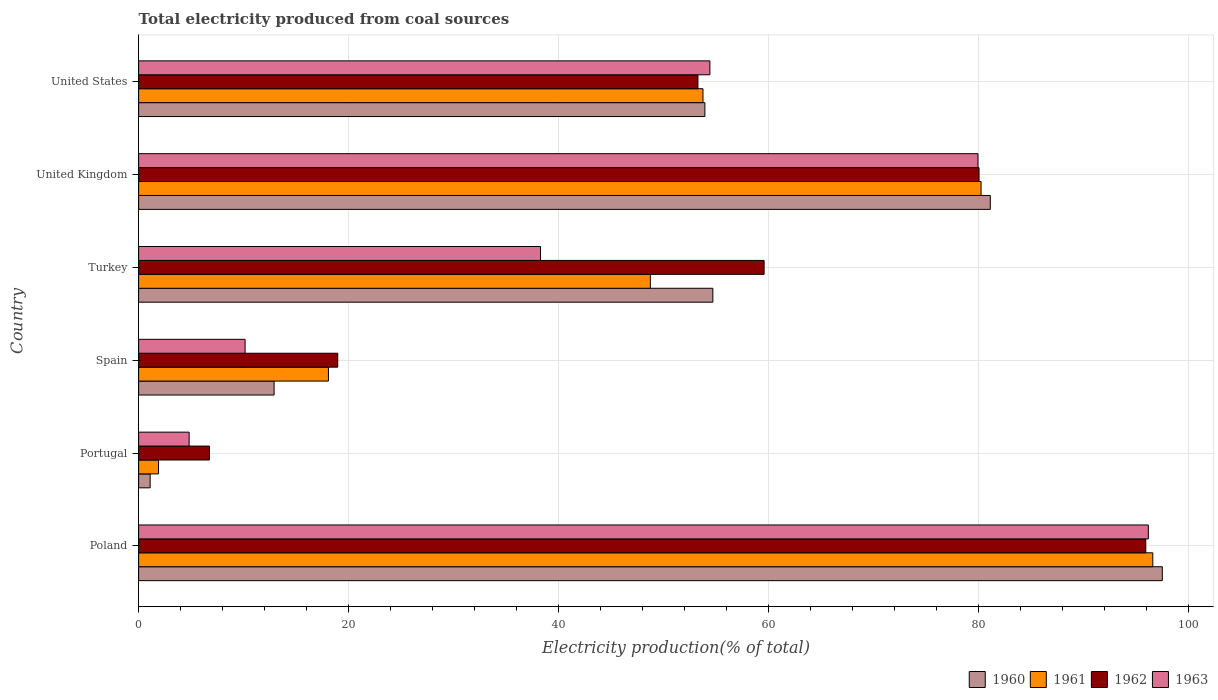How many groups of bars are there?
Provide a succinct answer. 6. How many bars are there on the 2nd tick from the bottom?
Give a very brief answer. 4. What is the total electricity produced in 1960 in Poland?
Your answer should be very brief. 97.46. Across all countries, what is the maximum total electricity produced in 1963?
Make the answer very short. 96.13. Across all countries, what is the minimum total electricity produced in 1961?
Offer a very short reply. 1.89. In which country was the total electricity produced in 1963 maximum?
Give a very brief answer. Poland. In which country was the total electricity produced in 1961 minimum?
Ensure brevity in your answer.  Portugal. What is the total total electricity produced in 1960 in the graph?
Provide a short and direct response. 301.13. What is the difference between the total electricity produced in 1961 in Poland and that in United States?
Keep it short and to the point. 42.83. What is the difference between the total electricity produced in 1963 in United States and the total electricity produced in 1960 in Spain?
Your answer should be compact. 41.49. What is the average total electricity produced in 1961 per country?
Your answer should be compact. 49.86. What is the difference between the total electricity produced in 1960 and total electricity produced in 1961 in Turkey?
Offer a very short reply. 5.95. In how many countries, is the total electricity produced in 1962 greater than 36 %?
Offer a very short reply. 4. What is the ratio of the total electricity produced in 1961 in Spain to that in United Kingdom?
Make the answer very short. 0.23. Is the total electricity produced in 1961 in Spain less than that in Turkey?
Your response must be concise. Yes. What is the difference between the highest and the second highest total electricity produced in 1963?
Offer a terse response. 16.22. What is the difference between the highest and the lowest total electricity produced in 1962?
Offer a terse response. 89.15. Is the sum of the total electricity produced in 1962 in Poland and Portugal greater than the maximum total electricity produced in 1963 across all countries?
Give a very brief answer. Yes. Is it the case that in every country, the sum of the total electricity produced in 1960 and total electricity produced in 1961 is greater than the total electricity produced in 1963?
Provide a short and direct response. No. How many bars are there?
Provide a short and direct response. 24. How many countries are there in the graph?
Your response must be concise. 6. Are the values on the major ticks of X-axis written in scientific E-notation?
Provide a short and direct response. No. Does the graph contain grids?
Your answer should be compact. Yes. How many legend labels are there?
Offer a very short reply. 4. What is the title of the graph?
Offer a very short reply. Total electricity produced from coal sources. What is the label or title of the X-axis?
Provide a short and direct response. Electricity production(% of total). What is the Electricity production(% of total) in 1960 in Poland?
Your response must be concise. 97.46. What is the Electricity production(% of total) of 1961 in Poland?
Keep it short and to the point. 96.56. What is the Electricity production(% of total) of 1962 in Poland?
Give a very brief answer. 95.89. What is the Electricity production(% of total) of 1963 in Poland?
Your response must be concise. 96.13. What is the Electricity production(% of total) of 1960 in Portugal?
Make the answer very short. 1.1. What is the Electricity production(% of total) in 1961 in Portugal?
Provide a succinct answer. 1.89. What is the Electricity production(% of total) of 1962 in Portugal?
Provide a succinct answer. 6.74. What is the Electricity production(% of total) of 1963 in Portugal?
Offer a very short reply. 4.81. What is the Electricity production(% of total) of 1960 in Spain?
Offer a terse response. 12.9. What is the Electricity production(% of total) in 1961 in Spain?
Your answer should be compact. 18.07. What is the Electricity production(% of total) in 1962 in Spain?
Give a very brief answer. 18.96. What is the Electricity production(% of total) of 1963 in Spain?
Provide a short and direct response. 10.14. What is the Electricity production(% of total) in 1960 in Turkey?
Offer a terse response. 54.67. What is the Electricity production(% of total) in 1961 in Turkey?
Ensure brevity in your answer.  48.72. What is the Electricity production(% of total) of 1962 in Turkey?
Your answer should be very brief. 59.55. What is the Electricity production(% of total) of 1963 in Turkey?
Offer a terse response. 38.26. What is the Electricity production(% of total) in 1960 in United Kingdom?
Keep it short and to the point. 81.09. What is the Electricity production(% of total) in 1961 in United Kingdom?
Your answer should be very brief. 80.21. What is the Electricity production(% of total) in 1962 in United Kingdom?
Make the answer very short. 80.01. What is the Electricity production(% of total) of 1963 in United Kingdom?
Ensure brevity in your answer.  79.91. What is the Electricity production(% of total) in 1960 in United States?
Your answer should be compact. 53.91. What is the Electricity production(% of total) of 1961 in United States?
Give a very brief answer. 53.73. What is the Electricity production(% of total) of 1962 in United States?
Provide a succinct answer. 53.25. What is the Electricity production(% of total) in 1963 in United States?
Make the answer very short. 54.39. Across all countries, what is the maximum Electricity production(% of total) of 1960?
Keep it short and to the point. 97.46. Across all countries, what is the maximum Electricity production(% of total) of 1961?
Provide a succinct answer. 96.56. Across all countries, what is the maximum Electricity production(% of total) in 1962?
Your answer should be very brief. 95.89. Across all countries, what is the maximum Electricity production(% of total) in 1963?
Your answer should be very brief. 96.13. Across all countries, what is the minimum Electricity production(% of total) of 1960?
Keep it short and to the point. 1.1. Across all countries, what is the minimum Electricity production(% of total) in 1961?
Your answer should be compact. 1.89. Across all countries, what is the minimum Electricity production(% of total) of 1962?
Your answer should be very brief. 6.74. Across all countries, what is the minimum Electricity production(% of total) in 1963?
Your answer should be very brief. 4.81. What is the total Electricity production(% of total) of 1960 in the graph?
Give a very brief answer. 301.13. What is the total Electricity production(% of total) of 1961 in the graph?
Your response must be concise. 299.18. What is the total Electricity production(% of total) of 1962 in the graph?
Your answer should be very brief. 314.4. What is the total Electricity production(% of total) in 1963 in the graph?
Provide a short and direct response. 283.64. What is the difference between the Electricity production(% of total) of 1960 in Poland and that in Portugal?
Ensure brevity in your answer.  96.36. What is the difference between the Electricity production(% of total) of 1961 in Poland and that in Portugal?
Your answer should be compact. 94.66. What is the difference between the Electricity production(% of total) of 1962 in Poland and that in Portugal?
Offer a terse response. 89.15. What is the difference between the Electricity production(% of total) of 1963 in Poland and that in Portugal?
Ensure brevity in your answer.  91.32. What is the difference between the Electricity production(% of total) in 1960 in Poland and that in Spain?
Your answer should be compact. 84.56. What is the difference between the Electricity production(% of total) of 1961 in Poland and that in Spain?
Offer a very short reply. 78.49. What is the difference between the Electricity production(% of total) in 1962 in Poland and that in Spain?
Provide a succinct answer. 76.93. What is the difference between the Electricity production(% of total) in 1963 in Poland and that in Spain?
Your answer should be very brief. 86. What is the difference between the Electricity production(% of total) in 1960 in Poland and that in Turkey?
Ensure brevity in your answer.  42.79. What is the difference between the Electricity production(% of total) in 1961 in Poland and that in Turkey?
Provide a succinct answer. 47.84. What is the difference between the Electricity production(% of total) in 1962 in Poland and that in Turkey?
Your response must be concise. 36.34. What is the difference between the Electricity production(% of total) of 1963 in Poland and that in Turkey?
Offer a very short reply. 57.87. What is the difference between the Electricity production(% of total) of 1960 in Poland and that in United Kingdom?
Ensure brevity in your answer.  16.38. What is the difference between the Electricity production(% of total) in 1961 in Poland and that in United Kingdom?
Give a very brief answer. 16.35. What is the difference between the Electricity production(% of total) in 1962 in Poland and that in United Kingdom?
Make the answer very short. 15.87. What is the difference between the Electricity production(% of total) of 1963 in Poland and that in United Kingdom?
Your answer should be compact. 16.22. What is the difference between the Electricity production(% of total) of 1960 in Poland and that in United States?
Your answer should be very brief. 43.55. What is the difference between the Electricity production(% of total) of 1961 in Poland and that in United States?
Your response must be concise. 42.83. What is the difference between the Electricity production(% of total) in 1962 in Poland and that in United States?
Your response must be concise. 42.64. What is the difference between the Electricity production(% of total) of 1963 in Poland and that in United States?
Offer a very short reply. 41.74. What is the difference between the Electricity production(% of total) of 1960 in Portugal and that in Spain?
Your response must be concise. -11.8. What is the difference between the Electricity production(% of total) of 1961 in Portugal and that in Spain?
Offer a very short reply. -16.18. What is the difference between the Electricity production(% of total) in 1962 in Portugal and that in Spain?
Offer a terse response. -12.22. What is the difference between the Electricity production(% of total) of 1963 in Portugal and that in Spain?
Make the answer very short. -5.33. What is the difference between the Electricity production(% of total) of 1960 in Portugal and that in Turkey?
Offer a terse response. -53.57. What is the difference between the Electricity production(% of total) of 1961 in Portugal and that in Turkey?
Ensure brevity in your answer.  -46.83. What is the difference between the Electricity production(% of total) in 1962 in Portugal and that in Turkey?
Make the answer very short. -52.81. What is the difference between the Electricity production(% of total) of 1963 in Portugal and that in Turkey?
Make the answer very short. -33.45. What is the difference between the Electricity production(% of total) in 1960 in Portugal and that in United Kingdom?
Provide a short and direct response. -79.99. What is the difference between the Electricity production(% of total) of 1961 in Portugal and that in United Kingdom?
Ensure brevity in your answer.  -78.31. What is the difference between the Electricity production(% of total) in 1962 in Portugal and that in United Kingdom?
Ensure brevity in your answer.  -73.27. What is the difference between the Electricity production(% of total) in 1963 in Portugal and that in United Kingdom?
Give a very brief answer. -75.1. What is the difference between the Electricity production(% of total) in 1960 in Portugal and that in United States?
Offer a very short reply. -52.81. What is the difference between the Electricity production(% of total) of 1961 in Portugal and that in United States?
Your answer should be compact. -51.84. What is the difference between the Electricity production(% of total) of 1962 in Portugal and that in United States?
Give a very brief answer. -46.51. What is the difference between the Electricity production(% of total) of 1963 in Portugal and that in United States?
Provide a short and direct response. -49.58. What is the difference between the Electricity production(% of total) of 1960 in Spain and that in Turkey?
Ensure brevity in your answer.  -41.77. What is the difference between the Electricity production(% of total) of 1961 in Spain and that in Turkey?
Offer a very short reply. -30.65. What is the difference between the Electricity production(% of total) in 1962 in Spain and that in Turkey?
Give a very brief answer. -40.59. What is the difference between the Electricity production(% of total) of 1963 in Spain and that in Turkey?
Your response must be concise. -28.13. What is the difference between the Electricity production(% of total) of 1960 in Spain and that in United Kingdom?
Provide a succinct answer. -68.19. What is the difference between the Electricity production(% of total) in 1961 in Spain and that in United Kingdom?
Offer a very short reply. -62.14. What is the difference between the Electricity production(% of total) in 1962 in Spain and that in United Kingdom?
Make the answer very short. -61.06. What is the difference between the Electricity production(% of total) in 1963 in Spain and that in United Kingdom?
Ensure brevity in your answer.  -69.78. What is the difference between the Electricity production(% of total) in 1960 in Spain and that in United States?
Offer a very short reply. -41.01. What is the difference between the Electricity production(% of total) in 1961 in Spain and that in United States?
Ensure brevity in your answer.  -35.66. What is the difference between the Electricity production(% of total) of 1962 in Spain and that in United States?
Your answer should be compact. -34.29. What is the difference between the Electricity production(% of total) in 1963 in Spain and that in United States?
Give a very brief answer. -44.25. What is the difference between the Electricity production(% of total) in 1960 in Turkey and that in United Kingdom?
Provide a short and direct response. -26.41. What is the difference between the Electricity production(% of total) of 1961 in Turkey and that in United Kingdom?
Make the answer very short. -31.49. What is the difference between the Electricity production(% of total) of 1962 in Turkey and that in United Kingdom?
Offer a very short reply. -20.46. What is the difference between the Electricity production(% of total) of 1963 in Turkey and that in United Kingdom?
Your response must be concise. -41.65. What is the difference between the Electricity production(% of total) of 1960 in Turkey and that in United States?
Make the answer very short. 0.76. What is the difference between the Electricity production(% of total) in 1961 in Turkey and that in United States?
Your answer should be very brief. -5.01. What is the difference between the Electricity production(% of total) of 1962 in Turkey and that in United States?
Give a very brief answer. 6.3. What is the difference between the Electricity production(% of total) of 1963 in Turkey and that in United States?
Make the answer very short. -16.13. What is the difference between the Electricity production(% of total) in 1960 in United Kingdom and that in United States?
Your answer should be compact. 27.17. What is the difference between the Electricity production(% of total) in 1961 in United Kingdom and that in United States?
Make the answer very short. 26.48. What is the difference between the Electricity production(% of total) in 1962 in United Kingdom and that in United States?
Offer a terse response. 26.76. What is the difference between the Electricity production(% of total) of 1963 in United Kingdom and that in United States?
Provide a succinct answer. 25.52. What is the difference between the Electricity production(% of total) in 1960 in Poland and the Electricity production(% of total) in 1961 in Portugal?
Offer a terse response. 95.57. What is the difference between the Electricity production(% of total) in 1960 in Poland and the Electricity production(% of total) in 1962 in Portugal?
Ensure brevity in your answer.  90.72. What is the difference between the Electricity production(% of total) in 1960 in Poland and the Electricity production(% of total) in 1963 in Portugal?
Your answer should be very brief. 92.65. What is the difference between the Electricity production(% of total) of 1961 in Poland and the Electricity production(% of total) of 1962 in Portugal?
Offer a terse response. 89.82. What is the difference between the Electricity production(% of total) in 1961 in Poland and the Electricity production(% of total) in 1963 in Portugal?
Give a very brief answer. 91.75. What is the difference between the Electricity production(% of total) in 1962 in Poland and the Electricity production(% of total) in 1963 in Portugal?
Ensure brevity in your answer.  91.08. What is the difference between the Electricity production(% of total) of 1960 in Poland and the Electricity production(% of total) of 1961 in Spain?
Your answer should be compact. 79.39. What is the difference between the Electricity production(% of total) in 1960 in Poland and the Electricity production(% of total) in 1962 in Spain?
Your response must be concise. 78.51. What is the difference between the Electricity production(% of total) in 1960 in Poland and the Electricity production(% of total) in 1963 in Spain?
Ensure brevity in your answer.  87.33. What is the difference between the Electricity production(% of total) of 1961 in Poland and the Electricity production(% of total) of 1962 in Spain?
Ensure brevity in your answer.  77.6. What is the difference between the Electricity production(% of total) in 1961 in Poland and the Electricity production(% of total) in 1963 in Spain?
Make the answer very short. 86.42. What is the difference between the Electricity production(% of total) in 1962 in Poland and the Electricity production(% of total) in 1963 in Spain?
Provide a short and direct response. 85.75. What is the difference between the Electricity production(% of total) in 1960 in Poland and the Electricity production(% of total) in 1961 in Turkey?
Offer a terse response. 48.74. What is the difference between the Electricity production(% of total) in 1960 in Poland and the Electricity production(% of total) in 1962 in Turkey?
Give a very brief answer. 37.91. What is the difference between the Electricity production(% of total) in 1960 in Poland and the Electricity production(% of total) in 1963 in Turkey?
Offer a terse response. 59.2. What is the difference between the Electricity production(% of total) of 1961 in Poland and the Electricity production(% of total) of 1962 in Turkey?
Keep it short and to the point. 37.01. What is the difference between the Electricity production(% of total) of 1961 in Poland and the Electricity production(% of total) of 1963 in Turkey?
Your answer should be compact. 58.29. What is the difference between the Electricity production(% of total) in 1962 in Poland and the Electricity production(% of total) in 1963 in Turkey?
Your response must be concise. 57.63. What is the difference between the Electricity production(% of total) in 1960 in Poland and the Electricity production(% of total) in 1961 in United Kingdom?
Your response must be concise. 17.26. What is the difference between the Electricity production(% of total) in 1960 in Poland and the Electricity production(% of total) in 1962 in United Kingdom?
Offer a very short reply. 17.45. What is the difference between the Electricity production(% of total) in 1960 in Poland and the Electricity production(% of total) in 1963 in United Kingdom?
Make the answer very short. 17.55. What is the difference between the Electricity production(% of total) of 1961 in Poland and the Electricity production(% of total) of 1962 in United Kingdom?
Offer a terse response. 16.54. What is the difference between the Electricity production(% of total) in 1961 in Poland and the Electricity production(% of total) in 1963 in United Kingdom?
Offer a very short reply. 16.64. What is the difference between the Electricity production(% of total) of 1962 in Poland and the Electricity production(% of total) of 1963 in United Kingdom?
Make the answer very short. 15.97. What is the difference between the Electricity production(% of total) of 1960 in Poland and the Electricity production(% of total) of 1961 in United States?
Your answer should be compact. 43.73. What is the difference between the Electricity production(% of total) in 1960 in Poland and the Electricity production(% of total) in 1962 in United States?
Your answer should be compact. 44.21. What is the difference between the Electricity production(% of total) of 1960 in Poland and the Electricity production(% of total) of 1963 in United States?
Your answer should be compact. 43.07. What is the difference between the Electricity production(% of total) of 1961 in Poland and the Electricity production(% of total) of 1962 in United States?
Ensure brevity in your answer.  43.31. What is the difference between the Electricity production(% of total) in 1961 in Poland and the Electricity production(% of total) in 1963 in United States?
Your answer should be compact. 42.17. What is the difference between the Electricity production(% of total) of 1962 in Poland and the Electricity production(% of total) of 1963 in United States?
Provide a short and direct response. 41.5. What is the difference between the Electricity production(% of total) of 1960 in Portugal and the Electricity production(% of total) of 1961 in Spain?
Your response must be concise. -16.97. What is the difference between the Electricity production(% of total) in 1960 in Portugal and the Electricity production(% of total) in 1962 in Spain?
Provide a succinct answer. -17.86. What is the difference between the Electricity production(% of total) in 1960 in Portugal and the Electricity production(% of total) in 1963 in Spain?
Your answer should be compact. -9.04. What is the difference between the Electricity production(% of total) of 1961 in Portugal and the Electricity production(% of total) of 1962 in Spain?
Your answer should be very brief. -17.06. What is the difference between the Electricity production(% of total) in 1961 in Portugal and the Electricity production(% of total) in 1963 in Spain?
Your response must be concise. -8.24. What is the difference between the Electricity production(% of total) of 1962 in Portugal and the Electricity production(% of total) of 1963 in Spain?
Ensure brevity in your answer.  -3.4. What is the difference between the Electricity production(% of total) of 1960 in Portugal and the Electricity production(% of total) of 1961 in Turkey?
Keep it short and to the point. -47.62. What is the difference between the Electricity production(% of total) in 1960 in Portugal and the Electricity production(% of total) in 1962 in Turkey?
Provide a succinct answer. -58.45. What is the difference between the Electricity production(% of total) of 1960 in Portugal and the Electricity production(% of total) of 1963 in Turkey?
Give a very brief answer. -37.16. What is the difference between the Electricity production(% of total) of 1961 in Portugal and the Electricity production(% of total) of 1962 in Turkey?
Your answer should be very brief. -57.66. What is the difference between the Electricity production(% of total) of 1961 in Portugal and the Electricity production(% of total) of 1963 in Turkey?
Provide a short and direct response. -36.37. What is the difference between the Electricity production(% of total) in 1962 in Portugal and the Electricity production(% of total) in 1963 in Turkey?
Offer a terse response. -31.52. What is the difference between the Electricity production(% of total) of 1960 in Portugal and the Electricity production(% of total) of 1961 in United Kingdom?
Provide a succinct answer. -79.11. What is the difference between the Electricity production(% of total) of 1960 in Portugal and the Electricity production(% of total) of 1962 in United Kingdom?
Your answer should be very brief. -78.92. What is the difference between the Electricity production(% of total) in 1960 in Portugal and the Electricity production(% of total) in 1963 in United Kingdom?
Keep it short and to the point. -78.82. What is the difference between the Electricity production(% of total) in 1961 in Portugal and the Electricity production(% of total) in 1962 in United Kingdom?
Keep it short and to the point. -78.12. What is the difference between the Electricity production(% of total) of 1961 in Portugal and the Electricity production(% of total) of 1963 in United Kingdom?
Your answer should be compact. -78.02. What is the difference between the Electricity production(% of total) of 1962 in Portugal and the Electricity production(% of total) of 1963 in United Kingdom?
Your response must be concise. -73.17. What is the difference between the Electricity production(% of total) in 1960 in Portugal and the Electricity production(% of total) in 1961 in United States?
Your answer should be compact. -52.63. What is the difference between the Electricity production(% of total) of 1960 in Portugal and the Electricity production(% of total) of 1962 in United States?
Make the answer very short. -52.15. What is the difference between the Electricity production(% of total) of 1960 in Portugal and the Electricity production(% of total) of 1963 in United States?
Ensure brevity in your answer.  -53.29. What is the difference between the Electricity production(% of total) of 1961 in Portugal and the Electricity production(% of total) of 1962 in United States?
Keep it short and to the point. -51.36. What is the difference between the Electricity production(% of total) of 1961 in Portugal and the Electricity production(% of total) of 1963 in United States?
Make the answer very short. -52.5. What is the difference between the Electricity production(% of total) of 1962 in Portugal and the Electricity production(% of total) of 1963 in United States?
Give a very brief answer. -47.65. What is the difference between the Electricity production(% of total) in 1960 in Spain and the Electricity production(% of total) in 1961 in Turkey?
Make the answer very short. -35.82. What is the difference between the Electricity production(% of total) of 1960 in Spain and the Electricity production(% of total) of 1962 in Turkey?
Offer a very short reply. -46.65. What is the difference between the Electricity production(% of total) in 1960 in Spain and the Electricity production(% of total) in 1963 in Turkey?
Offer a very short reply. -25.36. What is the difference between the Electricity production(% of total) in 1961 in Spain and the Electricity production(% of total) in 1962 in Turkey?
Ensure brevity in your answer.  -41.48. What is the difference between the Electricity production(% of total) in 1961 in Spain and the Electricity production(% of total) in 1963 in Turkey?
Ensure brevity in your answer.  -20.19. What is the difference between the Electricity production(% of total) of 1962 in Spain and the Electricity production(% of total) of 1963 in Turkey?
Ensure brevity in your answer.  -19.31. What is the difference between the Electricity production(% of total) in 1960 in Spain and the Electricity production(% of total) in 1961 in United Kingdom?
Make the answer very short. -67.31. What is the difference between the Electricity production(% of total) of 1960 in Spain and the Electricity production(% of total) of 1962 in United Kingdom?
Offer a terse response. -67.12. What is the difference between the Electricity production(% of total) in 1960 in Spain and the Electricity production(% of total) in 1963 in United Kingdom?
Your answer should be compact. -67.02. What is the difference between the Electricity production(% of total) in 1961 in Spain and the Electricity production(% of total) in 1962 in United Kingdom?
Your answer should be compact. -61.94. What is the difference between the Electricity production(% of total) in 1961 in Spain and the Electricity production(% of total) in 1963 in United Kingdom?
Your response must be concise. -61.84. What is the difference between the Electricity production(% of total) of 1962 in Spain and the Electricity production(% of total) of 1963 in United Kingdom?
Keep it short and to the point. -60.96. What is the difference between the Electricity production(% of total) of 1960 in Spain and the Electricity production(% of total) of 1961 in United States?
Give a very brief answer. -40.83. What is the difference between the Electricity production(% of total) in 1960 in Spain and the Electricity production(% of total) in 1962 in United States?
Your answer should be very brief. -40.35. What is the difference between the Electricity production(% of total) of 1960 in Spain and the Electricity production(% of total) of 1963 in United States?
Ensure brevity in your answer.  -41.49. What is the difference between the Electricity production(% of total) in 1961 in Spain and the Electricity production(% of total) in 1962 in United States?
Ensure brevity in your answer.  -35.18. What is the difference between the Electricity production(% of total) in 1961 in Spain and the Electricity production(% of total) in 1963 in United States?
Ensure brevity in your answer.  -36.32. What is the difference between the Electricity production(% of total) of 1962 in Spain and the Electricity production(% of total) of 1963 in United States?
Provide a succinct answer. -35.43. What is the difference between the Electricity production(% of total) in 1960 in Turkey and the Electricity production(% of total) in 1961 in United Kingdom?
Give a very brief answer. -25.54. What is the difference between the Electricity production(% of total) in 1960 in Turkey and the Electricity production(% of total) in 1962 in United Kingdom?
Offer a terse response. -25.34. What is the difference between the Electricity production(% of total) in 1960 in Turkey and the Electricity production(% of total) in 1963 in United Kingdom?
Provide a succinct answer. -25.24. What is the difference between the Electricity production(% of total) of 1961 in Turkey and the Electricity production(% of total) of 1962 in United Kingdom?
Give a very brief answer. -31.29. What is the difference between the Electricity production(% of total) in 1961 in Turkey and the Electricity production(% of total) in 1963 in United Kingdom?
Make the answer very short. -31.19. What is the difference between the Electricity production(% of total) of 1962 in Turkey and the Electricity production(% of total) of 1963 in United Kingdom?
Keep it short and to the point. -20.36. What is the difference between the Electricity production(% of total) in 1960 in Turkey and the Electricity production(% of total) in 1961 in United States?
Offer a terse response. 0.94. What is the difference between the Electricity production(% of total) in 1960 in Turkey and the Electricity production(% of total) in 1962 in United States?
Your answer should be very brief. 1.42. What is the difference between the Electricity production(% of total) of 1960 in Turkey and the Electricity production(% of total) of 1963 in United States?
Provide a succinct answer. 0.28. What is the difference between the Electricity production(% of total) of 1961 in Turkey and the Electricity production(% of total) of 1962 in United States?
Provide a short and direct response. -4.53. What is the difference between the Electricity production(% of total) in 1961 in Turkey and the Electricity production(% of total) in 1963 in United States?
Provide a short and direct response. -5.67. What is the difference between the Electricity production(% of total) in 1962 in Turkey and the Electricity production(% of total) in 1963 in United States?
Keep it short and to the point. 5.16. What is the difference between the Electricity production(% of total) of 1960 in United Kingdom and the Electricity production(% of total) of 1961 in United States?
Keep it short and to the point. 27.36. What is the difference between the Electricity production(% of total) in 1960 in United Kingdom and the Electricity production(% of total) in 1962 in United States?
Your answer should be compact. 27.84. What is the difference between the Electricity production(% of total) in 1960 in United Kingdom and the Electricity production(% of total) in 1963 in United States?
Give a very brief answer. 26.7. What is the difference between the Electricity production(% of total) in 1961 in United Kingdom and the Electricity production(% of total) in 1962 in United States?
Give a very brief answer. 26.96. What is the difference between the Electricity production(% of total) of 1961 in United Kingdom and the Electricity production(% of total) of 1963 in United States?
Your response must be concise. 25.82. What is the difference between the Electricity production(% of total) of 1962 in United Kingdom and the Electricity production(% of total) of 1963 in United States?
Give a very brief answer. 25.62. What is the average Electricity production(% of total) of 1960 per country?
Provide a succinct answer. 50.19. What is the average Electricity production(% of total) of 1961 per country?
Offer a terse response. 49.86. What is the average Electricity production(% of total) of 1962 per country?
Give a very brief answer. 52.4. What is the average Electricity production(% of total) in 1963 per country?
Your answer should be very brief. 47.27. What is the difference between the Electricity production(% of total) of 1960 and Electricity production(% of total) of 1961 in Poland?
Keep it short and to the point. 0.91. What is the difference between the Electricity production(% of total) of 1960 and Electricity production(% of total) of 1962 in Poland?
Make the answer very short. 1.57. What is the difference between the Electricity production(% of total) of 1960 and Electricity production(% of total) of 1963 in Poland?
Provide a short and direct response. 1.33. What is the difference between the Electricity production(% of total) of 1961 and Electricity production(% of total) of 1962 in Poland?
Ensure brevity in your answer.  0.67. What is the difference between the Electricity production(% of total) of 1961 and Electricity production(% of total) of 1963 in Poland?
Your answer should be compact. 0.43. What is the difference between the Electricity production(% of total) in 1962 and Electricity production(% of total) in 1963 in Poland?
Your answer should be very brief. -0.24. What is the difference between the Electricity production(% of total) in 1960 and Electricity production(% of total) in 1961 in Portugal?
Your answer should be very brief. -0.8. What is the difference between the Electricity production(% of total) in 1960 and Electricity production(% of total) in 1962 in Portugal?
Ensure brevity in your answer.  -5.64. What is the difference between the Electricity production(% of total) of 1960 and Electricity production(% of total) of 1963 in Portugal?
Ensure brevity in your answer.  -3.71. What is the difference between the Electricity production(% of total) of 1961 and Electricity production(% of total) of 1962 in Portugal?
Your answer should be very brief. -4.85. What is the difference between the Electricity production(% of total) of 1961 and Electricity production(% of total) of 1963 in Portugal?
Your answer should be compact. -2.91. What is the difference between the Electricity production(% of total) in 1962 and Electricity production(% of total) in 1963 in Portugal?
Ensure brevity in your answer.  1.93. What is the difference between the Electricity production(% of total) in 1960 and Electricity production(% of total) in 1961 in Spain?
Ensure brevity in your answer.  -5.17. What is the difference between the Electricity production(% of total) of 1960 and Electricity production(% of total) of 1962 in Spain?
Give a very brief answer. -6.06. What is the difference between the Electricity production(% of total) of 1960 and Electricity production(% of total) of 1963 in Spain?
Give a very brief answer. 2.76. What is the difference between the Electricity production(% of total) of 1961 and Electricity production(% of total) of 1962 in Spain?
Your response must be concise. -0.88. What is the difference between the Electricity production(% of total) in 1961 and Electricity production(% of total) in 1963 in Spain?
Keep it short and to the point. 7.94. What is the difference between the Electricity production(% of total) in 1962 and Electricity production(% of total) in 1963 in Spain?
Your answer should be very brief. 8.82. What is the difference between the Electricity production(% of total) in 1960 and Electricity production(% of total) in 1961 in Turkey?
Your answer should be compact. 5.95. What is the difference between the Electricity production(% of total) of 1960 and Electricity production(% of total) of 1962 in Turkey?
Your answer should be very brief. -4.88. What is the difference between the Electricity production(% of total) of 1960 and Electricity production(% of total) of 1963 in Turkey?
Provide a succinct answer. 16.41. What is the difference between the Electricity production(% of total) of 1961 and Electricity production(% of total) of 1962 in Turkey?
Keep it short and to the point. -10.83. What is the difference between the Electricity production(% of total) in 1961 and Electricity production(% of total) in 1963 in Turkey?
Provide a succinct answer. 10.46. What is the difference between the Electricity production(% of total) in 1962 and Electricity production(% of total) in 1963 in Turkey?
Your response must be concise. 21.29. What is the difference between the Electricity production(% of total) of 1960 and Electricity production(% of total) of 1961 in United Kingdom?
Your response must be concise. 0.88. What is the difference between the Electricity production(% of total) of 1960 and Electricity production(% of total) of 1962 in United Kingdom?
Offer a very short reply. 1.07. What is the difference between the Electricity production(% of total) in 1960 and Electricity production(% of total) in 1963 in United Kingdom?
Ensure brevity in your answer.  1.17. What is the difference between the Electricity production(% of total) of 1961 and Electricity production(% of total) of 1962 in United Kingdom?
Your answer should be compact. 0.19. What is the difference between the Electricity production(% of total) in 1961 and Electricity production(% of total) in 1963 in United Kingdom?
Provide a short and direct response. 0.29. What is the difference between the Electricity production(% of total) of 1962 and Electricity production(% of total) of 1963 in United Kingdom?
Provide a succinct answer. 0.1. What is the difference between the Electricity production(% of total) in 1960 and Electricity production(% of total) in 1961 in United States?
Offer a very short reply. 0.18. What is the difference between the Electricity production(% of total) of 1960 and Electricity production(% of total) of 1962 in United States?
Your answer should be very brief. 0.66. What is the difference between the Electricity production(% of total) in 1960 and Electricity production(% of total) in 1963 in United States?
Give a very brief answer. -0.48. What is the difference between the Electricity production(% of total) in 1961 and Electricity production(% of total) in 1962 in United States?
Your answer should be very brief. 0.48. What is the difference between the Electricity production(% of total) of 1961 and Electricity production(% of total) of 1963 in United States?
Give a very brief answer. -0.66. What is the difference between the Electricity production(% of total) of 1962 and Electricity production(% of total) of 1963 in United States?
Offer a very short reply. -1.14. What is the ratio of the Electricity production(% of total) of 1960 in Poland to that in Portugal?
Your answer should be very brief. 88.77. What is the ratio of the Electricity production(% of total) of 1961 in Poland to that in Portugal?
Offer a terse response. 50.97. What is the ratio of the Electricity production(% of total) in 1962 in Poland to that in Portugal?
Make the answer very short. 14.23. What is the ratio of the Electricity production(% of total) of 1963 in Poland to that in Portugal?
Ensure brevity in your answer.  19.99. What is the ratio of the Electricity production(% of total) of 1960 in Poland to that in Spain?
Give a very brief answer. 7.56. What is the ratio of the Electricity production(% of total) of 1961 in Poland to that in Spain?
Your response must be concise. 5.34. What is the ratio of the Electricity production(% of total) in 1962 in Poland to that in Spain?
Give a very brief answer. 5.06. What is the ratio of the Electricity production(% of total) in 1963 in Poland to that in Spain?
Offer a terse response. 9.48. What is the ratio of the Electricity production(% of total) in 1960 in Poland to that in Turkey?
Ensure brevity in your answer.  1.78. What is the ratio of the Electricity production(% of total) of 1961 in Poland to that in Turkey?
Offer a very short reply. 1.98. What is the ratio of the Electricity production(% of total) of 1962 in Poland to that in Turkey?
Make the answer very short. 1.61. What is the ratio of the Electricity production(% of total) in 1963 in Poland to that in Turkey?
Your answer should be very brief. 2.51. What is the ratio of the Electricity production(% of total) in 1960 in Poland to that in United Kingdom?
Your answer should be compact. 1.2. What is the ratio of the Electricity production(% of total) in 1961 in Poland to that in United Kingdom?
Your response must be concise. 1.2. What is the ratio of the Electricity production(% of total) of 1962 in Poland to that in United Kingdom?
Give a very brief answer. 1.2. What is the ratio of the Electricity production(% of total) of 1963 in Poland to that in United Kingdom?
Ensure brevity in your answer.  1.2. What is the ratio of the Electricity production(% of total) in 1960 in Poland to that in United States?
Your answer should be compact. 1.81. What is the ratio of the Electricity production(% of total) of 1961 in Poland to that in United States?
Make the answer very short. 1.8. What is the ratio of the Electricity production(% of total) in 1962 in Poland to that in United States?
Offer a very short reply. 1.8. What is the ratio of the Electricity production(% of total) of 1963 in Poland to that in United States?
Make the answer very short. 1.77. What is the ratio of the Electricity production(% of total) of 1960 in Portugal to that in Spain?
Provide a succinct answer. 0.09. What is the ratio of the Electricity production(% of total) of 1961 in Portugal to that in Spain?
Offer a very short reply. 0.1. What is the ratio of the Electricity production(% of total) in 1962 in Portugal to that in Spain?
Make the answer very short. 0.36. What is the ratio of the Electricity production(% of total) in 1963 in Portugal to that in Spain?
Make the answer very short. 0.47. What is the ratio of the Electricity production(% of total) of 1960 in Portugal to that in Turkey?
Your response must be concise. 0.02. What is the ratio of the Electricity production(% of total) in 1961 in Portugal to that in Turkey?
Your answer should be very brief. 0.04. What is the ratio of the Electricity production(% of total) in 1962 in Portugal to that in Turkey?
Provide a succinct answer. 0.11. What is the ratio of the Electricity production(% of total) of 1963 in Portugal to that in Turkey?
Your response must be concise. 0.13. What is the ratio of the Electricity production(% of total) of 1960 in Portugal to that in United Kingdom?
Your answer should be compact. 0.01. What is the ratio of the Electricity production(% of total) in 1961 in Portugal to that in United Kingdom?
Offer a very short reply. 0.02. What is the ratio of the Electricity production(% of total) of 1962 in Portugal to that in United Kingdom?
Offer a terse response. 0.08. What is the ratio of the Electricity production(% of total) of 1963 in Portugal to that in United Kingdom?
Make the answer very short. 0.06. What is the ratio of the Electricity production(% of total) in 1960 in Portugal to that in United States?
Your answer should be very brief. 0.02. What is the ratio of the Electricity production(% of total) of 1961 in Portugal to that in United States?
Give a very brief answer. 0.04. What is the ratio of the Electricity production(% of total) of 1962 in Portugal to that in United States?
Your answer should be very brief. 0.13. What is the ratio of the Electricity production(% of total) of 1963 in Portugal to that in United States?
Give a very brief answer. 0.09. What is the ratio of the Electricity production(% of total) of 1960 in Spain to that in Turkey?
Your response must be concise. 0.24. What is the ratio of the Electricity production(% of total) in 1961 in Spain to that in Turkey?
Provide a succinct answer. 0.37. What is the ratio of the Electricity production(% of total) of 1962 in Spain to that in Turkey?
Provide a short and direct response. 0.32. What is the ratio of the Electricity production(% of total) of 1963 in Spain to that in Turkey?
Make the answer very short. 0.26. What is the ratio of the Electricity production(% of total) in 1960 in Spain to that in United Kingdom?
Ensure brevity in your answer.  0.16. What is the ratio of the Electricity production(% of total) in 1961 in Spain to that in United Kingdom?
Offer a terse response. 0.23. What is the ratio of the Electricity production(% of total) of 1962 in Spain to that in United Kingdom?
Offer a very short reply. 0.24. What is the ratio of the Electricity production(% of total) in 1963 in Spain to that in United Kingdom?
Offer a very short reply. 0.13. What is the ratio of the Electricity production(% of total) of 1960 in Spain to that in United States?
Provide a short and direct response. 0.24. What is the ratio of the Electricity production(% of total) in 1961 in Spain to that in United States?
Ensure brevity in your answer.  0.34. What is the ratio of the Electricity production(% of total) in 1962 in Spain to that in United States?
Your answer should be very brief. 0.36. What is the ratio of the Electricity production(% of total) in 1963 in Spain to that in United States?
Ensure brevity in your answer.  0.19. What is the ratio of the Electricity production(% of total) in 1960 in Turkey to that in United Kingdom?
Give a very brief answer. 0.67. What is the ratio of the Electricity production(% of total) of 1961 in Turkey to that in United Kingdom?
Your answer should be compact. 0.61. What is the ratio of the Electricity production(% of total) of 1962 in Turkey to that in United Kingdom?
Give a very brief answer. 0.74. What is the ratio of the Electricity production(% of total) of 1963 in Turkey to that in United Kingdom?
Your answer should be very brief. 0.48. What is the ratio of the Electricity production(% of total) of 1960 in Turkey to that in United States?
Offer a very short reply. 1.01. What is the ratio of the Electricity production(% of total) in 1961 in Turkey to that in United States?
Keep it short and to the point. 0.91. What is the ratio of the Electricity production(% of total) of 1962 in Turkey to that in United States?
Your response must be concise. 1.12. What is the ratio of the Electricity production(% of total) of 1963 in Turkey to that in United States?
Provide a succinct answer. 0.7. What is the ratio of the Electricity production(% of total) of 1960 in United Kingdom to that in United States?
Offer a terse response. 1.5. What is the ratio of the Electricity production(% of total) in 1961 in United Kingdom to that in United States?
Offer a very short reply. 1.49. What is the ratio of the Electricity production(% of total) in 1962 in United Kingdom to that in United States?
Make the answer very short. 1.5. What is the ratio of the Electricity production(% of total) of 1963 in United Kingdom to that in United States?
Give a very brief answer. 1.47. What is the difference between the highest and the second highest Electricity production(% of total) of 1960?
Provide a short and direct response. 16.38. What is the difference between the highest and the second highest Electricity production(% of total) in 1961?
Make the answer very short. 16.35. What is the difference between the highest and the second highest Electricity production(% of total) in 1962?
Provide a short and direct response. 15.87. What is the difference between the highest and the second highest Electricity production(% of total) in 1963?
Offer a very short reply. 16.22. What is the difference between the highest and the lowest Electricity production(% of total) of 1960?
Your answer should be very brief. 96.36. What is the difference between the highest and the lowest Electricity production(% of total) in 1961?
Keep it short and to the point. 94.66. What is the difference between the highest and the lowest Electricity production(% of total) in 1962?
Ensure brevity in your answer.  89.15. What is the difference between the highest and the lowest Electricity production(% of total) of 1963?
Your answer should be compact. 91.32. 